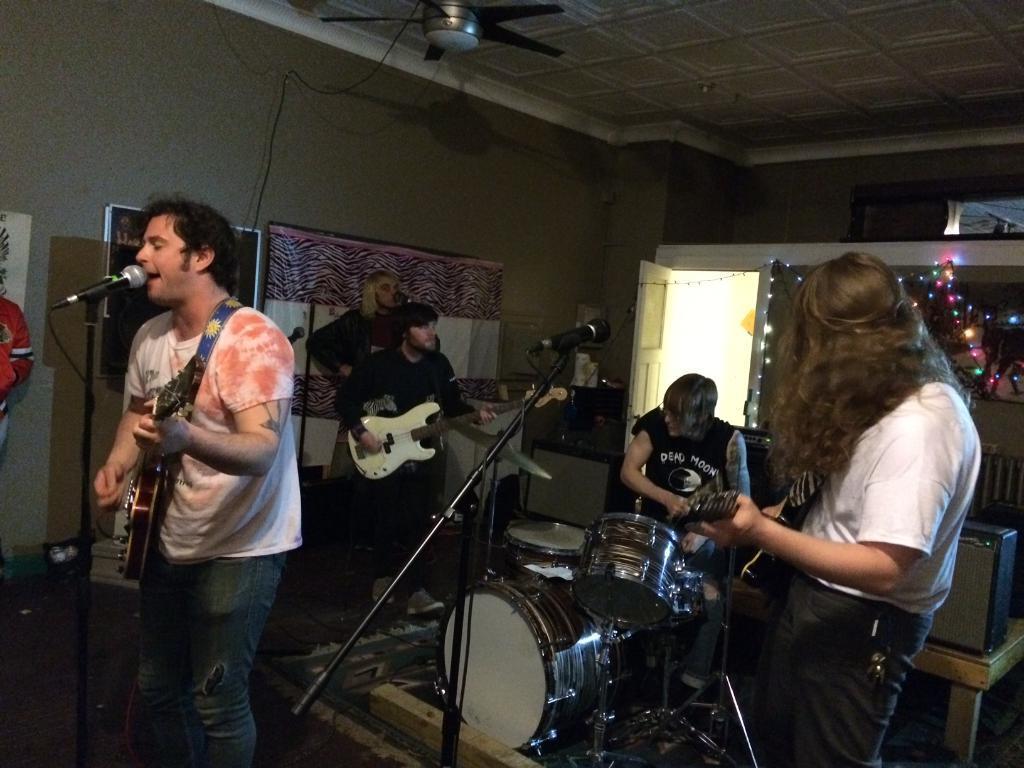Can you describe this image briefly? In this picture I can see three persons standing and holding the guitars, there are two persons standing, another person sitting, there are drums, there are miles with the miles stands, there are speakers, fan, there is a board, frame and papers to the wall, there are lights, door and a carpet. 